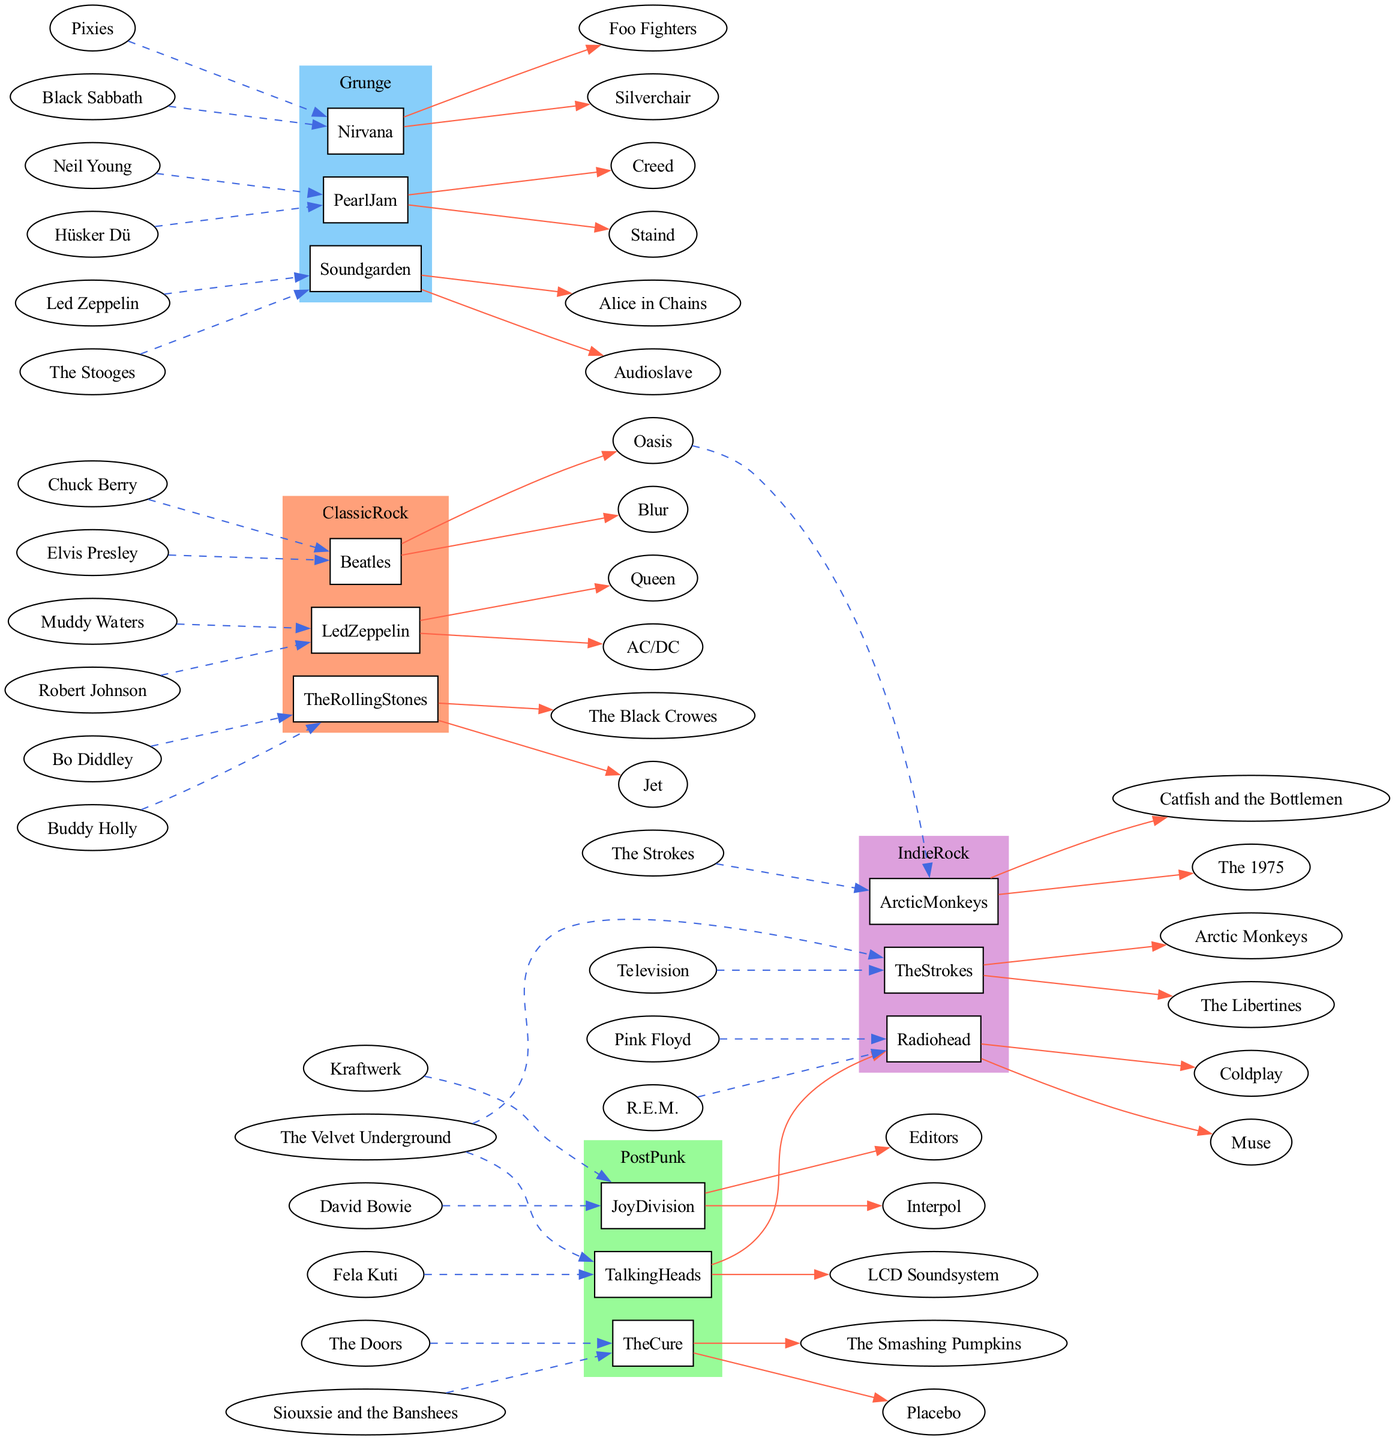What are the three genres represented in the diagram? The diagram includes four main genres: Classic Rock, Post Punk, Grunge, and Indie Rock. The question specifically asks for three of them, so I can simply list any three from the genres present. For example, Classic Rock, Post Punk, and Grunge can be selected.
Answer: Classic Rock, Post Punk, Grunge Which artist influenced The Cure? To answer this question, I can look at the section for The Cure in the diagram and identify its influences. According to the data, The Cure was influenced by The Doors and Siouxsie and the Banshees. Therefore, I can list either of these artists as having influenced The Cure.
Answer: The Doors What is a band influenced by Nirvana? By checking Nirvana's section, I can see its influenced bands, which include Foo Fighters and Silverchair. I can provide either of these two bands as an answer to the question.
Answer: Foo Fighters How many artists fall under the Grunge genre? In the Grunge section of the diagram, three artists are listed: Nirvana, Pearl Jam, and Soundgarden. The question asks for the total count of these artists, which can be found by counting them directly.
Answer: 3 Which band influenced both The Strokes and Arctic Monkeys? Referring to the sections for both artists, I can see that The Velvet Underground influenced The Strokes, and The Strokes also influenced Arctic Monkeys. However, I need to consider the flow of influence correctly. The direct answer pertains to The Strokes since they share an influence.
Answer: The Velvet Underground Which artist influenced the most other artists? To determine this, I will need to identify how many artists each musician has influenced. Upon reviewing the diagram, I find that the Beatles influenced Oasis and Blur, while Led Zeppelin influenced Queen and AC/DC, and Nirvana influenced Foo Fighters and Silverchair. The Beatles, Led Zeppelin, and Nirvana all influenced two artists each. Therefore, the answer must reflect one of these artists even if they are tied for influence.
Answer: The Beatles Name a classic rock band that influenced a grunge band. Since I see that Led Zeppelin influenced Soundgarden, I can answer the question accordingly by citing this unique relationship between genres.
Answer: Led Zeppelin What color represents Indie Rock in the diagram? The graph's color scheme indicates specific colors to genres; for Indie Rock, the condition states it is represented by the color DDA0DD. The correct answer can be extracted directly from the visual features.
Answer: DDA0DD 